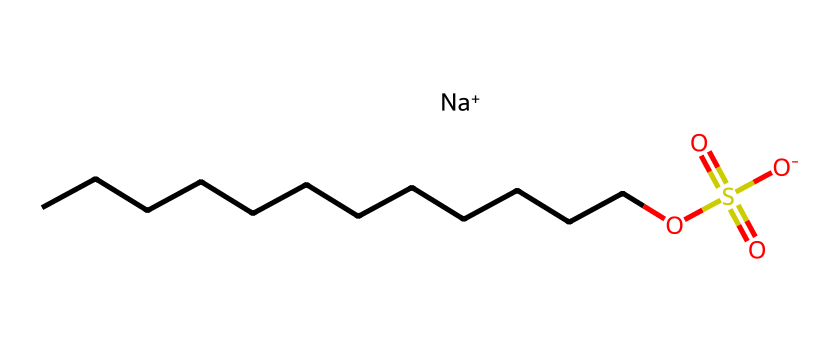What is the total number of carbon atoms in this molecule? The SMILES representation reveals that there are 12 carbon atoms in the long hydrocarbon chain (CCCCCCCCCCCC). Each letter "C" represents one carbon atom, and there are 12 consecutive "C" characters.
Answer: 12 How many oxygen atoms are present in the structure? Analyzing the SMILES notation, there are 4 occurrences of the letter "O." Two "O" atoms are part of the sulfate group (OS(=O)(=O)), and the other two are connected to the sulfate as hydroxyls.
Answer: 4 What type of functional group does sodium lauryl sulfate contain? The structure shows that it contains a sulfate group (the OS(=O)(=O) part), which is characteristic of surfactants. This group is responsible for its surfactant properties.
Answer: sulfate What is the charge of the sodium ion in this compound? The SMILES notation includes "[Na+]", indicating that sodium has a positive charge. The plus sign indicates that it is a cation.
Answer: positive What structural feature of sodium lauryl sulfate contributes to its surfactant ability? The long hydrophobic hydrocarbon chain (the chain of carbon atoms) combined with the hydrophilic sulfate head (the sulfate group) exemplifies the amphiphilic nature of surfactants, allowing them to reduce surface tension.
Answer: amphiphilic structure How does the presence of the sulfate group affect the solubility of sodium lauryl sulfate in water? The sulfate group is polar, increasing the compound's hydrophilicity, thus enhancing its solubility in water. This polar group interacts favorably with the water molecules, allowing it to dissolve.
Answer: increases solubility 